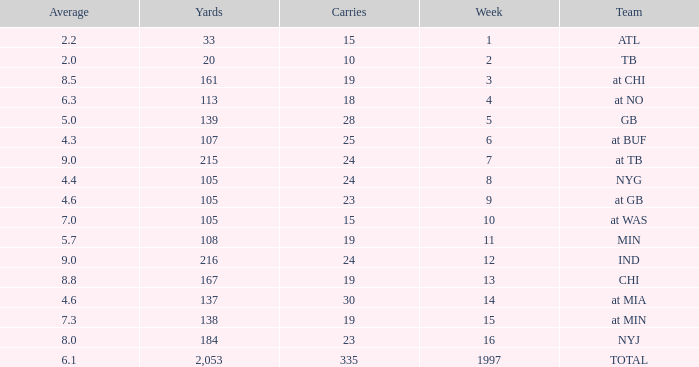Which Average has Yards larger than 167, and a Team of at tb, and a Week larger than 7? None. 